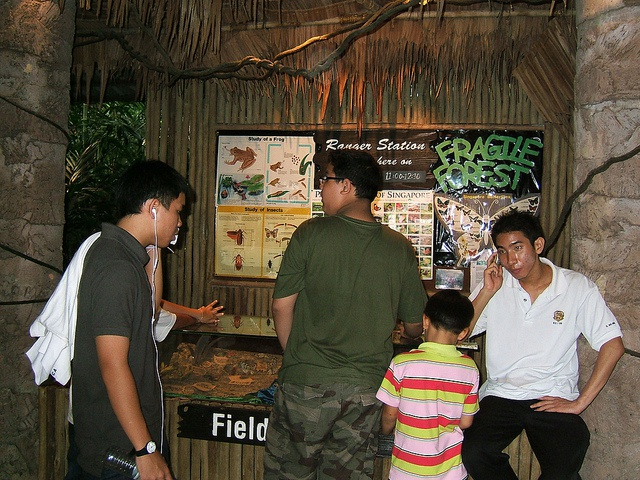Describe the objects in this image and their specific colors. I can see people in black, darkgreen, and gray tones, people in black, lightgray, and gray tones, people in black, brown, and maroon tones, people in black, pink, khaki, and brown tones, and bottle in black, gray, and darkgray tones in this image. 